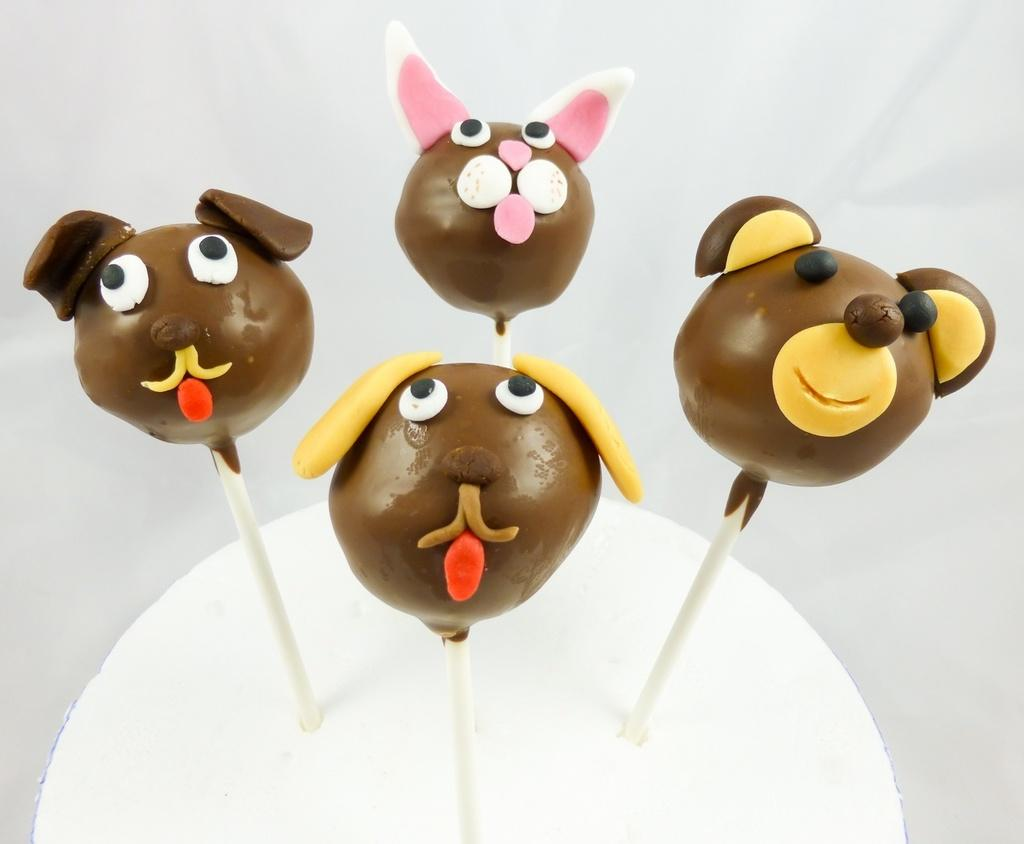How many lollipops are visible in the image? There are four lollipops in the image. What are the lollipops placed on? The lollipops are on an object. What color is the background of the image? The background of the image is white in color. What type of clam is visible in the image? There is no clam present in the image; it features four lollipops on an object with a white background. 